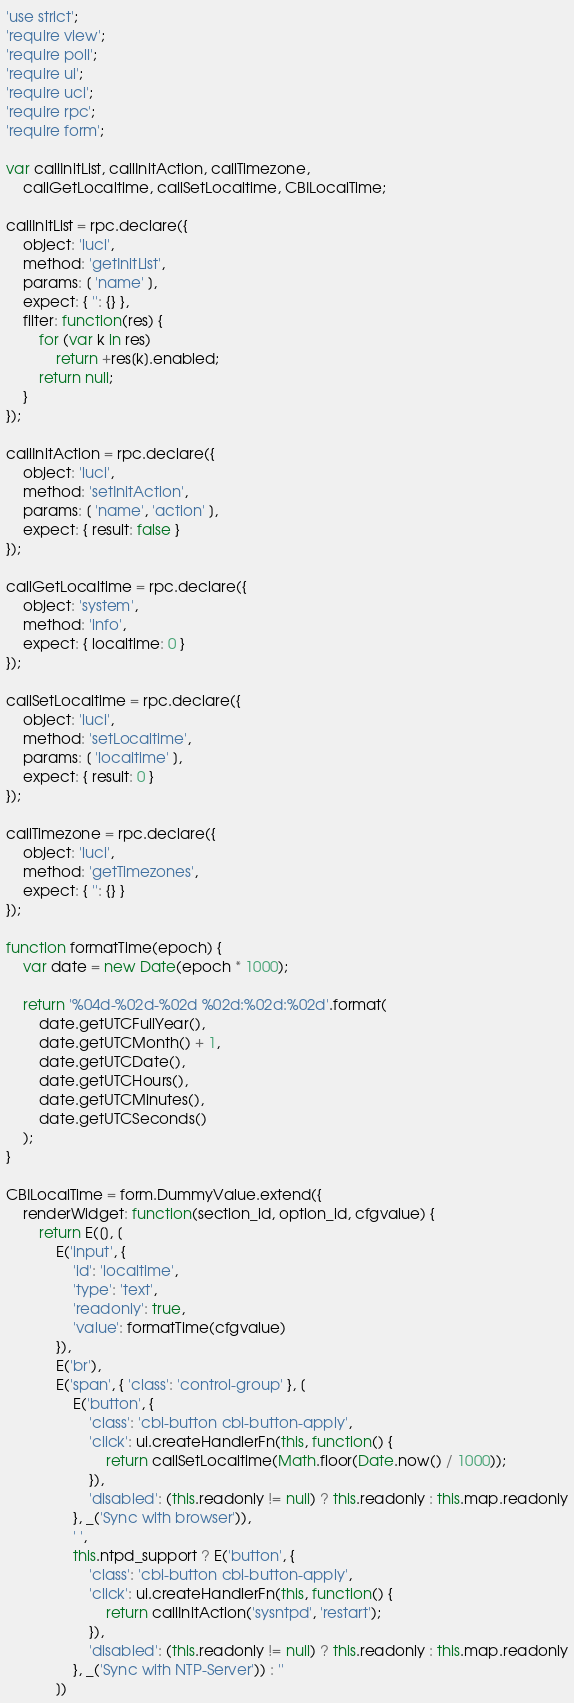Convert code to text. <code><loc_0><loc_0><loc_500><loc_500><_JavaScript_>'use strict';
'require view';
'require poll';
'require ui';
'require uci';
'require rpc';
'require form';

var callInitList, callInitAction, callTimezone,
    callGetLocaltime, callSetLocaltime, CBILocalTime;

callInitList = rpc.declare({
	object: 'luci',
	method: 'getInitList',
	params: [ 'name' ],
	expect: { '': {} },
	filter: function(res) {
		for (var k in res)
			return +res[k].enabled;
		return null;
	}
});

callInitAction = rpc.declare({
	object: 'luci',
	method: 'setInitAction',
	params: [ 'name', 'action' ],
	expect: { result: false }
});

callGetLocaltime = rpc.declare({
	object: 'system',
	method: 'info',
	expect: { localtime: 0 }
});

callSetLocaltime = rpc.declare({
	object: 'luci',
	method: 'setLocaltime',
	params: [ 'localtime' ],
	expect: { result: 0 }
});

callTimezone = rpc.declare({
	object: 'luci',
	method: 'getTimezones',
	expect: { '': {} }
});

function formatTime(epoch) {
	var date = new Date(epoch * 1000);

	return '%04d-%02d-%02d %02d:%02d:%02d'.format(
		date.getUTCFullYear(),
		date.getUTCMonth() + 1,
		date.getUTCDate(),
		date.getUTCHours(),
		date.getUTCMinutes(),
		date.getUTCSeconds()
	);
}

CBILocalTime = form.DummyValue.extend({
	renderWidget: function(section_id, option_id, cfgvalue) {
		return E([], [
			E('input', {
				'id': 'localtime',
				'type': 'text',
				'readonly': true,
				'value': formatTime(cfgvalue)
			}),
			E('br'),
			E('span', { 'class': 'control-group' }, [
				E('button', {
					'class': 'cbi-button cbi-button-apply',
					'click': ui.createHandlerFn(this, function() {
						return callSetLocaltime(Math.floor(Date.now() / 1000));
					}),
					'disabled': (this.readonly != null) ? this.readonly : this.map.readonly
				}, _('Sync with browser')),
				' ',
				this.ntpd_support ? E('button', {
					'class': 'cbi-button cbi-button-apply',
					'click': ui.createHandlerFn(this, function() {
						return callInitAction('sysntpd', 'restart');
					}),
					'disabled': (this.readonly != null) ? this.readonly : this.map.readonly
				}, _('Sync with NTP-Server')) : ''
			])</code> 